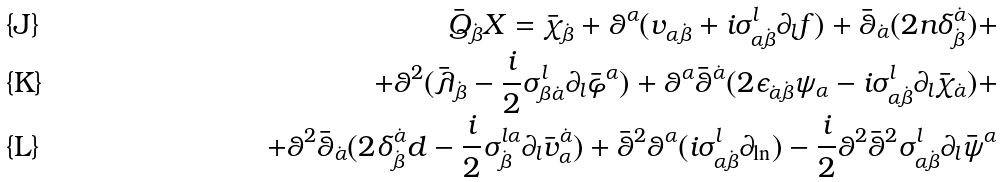Convert formula to latex. <formula><loc_0><loc_0><loc_500><loc_500>\bar { Q } _ { \dot { \beta } } X = \bar { \chi } _ { \dot { \beta } } + \theta ^ { \alpha } ( v _ { \alpha \dot { \beta } } + i \sigma _ { \alpha \dot { \beta } } ^ { l } \partial _ { l } f ) + \bar { \theta } _ { \dot { \alpha } } ( 2 n \delta _ { \dot { \beta } } ^ { \dot { \alpha } } ) + \\ + \theta ^ { 2 } ( \bar { \lambda } _ { \dot { \beta } } - \frac { i } { 2 } \sigma _ { \beta \dot { \alpha } } ^ { l } \partial _ { l } \bar { \varphi } ^ { \alpha } ) + \theta ^ { \alpha } \bar { \theta } ^ { \dot { \alpha } } ( 2 \epsilon _ { \dot { \alpha } \dot { \beta } } \psi _ { \alpha } - i \sigma _ { \alpha \dot { \beta } } ^ { l } \partial _ { l } \bar { \chi } _ { \dot { \alpha } } ) + \\ + \theta ^ { 2 } \bar { \theta } _ { \dot { \alpha } } ( 2 \delta _ { \dot { \beta } } ^ { \dot { \alpha } } d - \frac { i } { 2 } \sigma _ { \dot { \beta } } ^ { l \alpha } \partial _ { l } \bar { v } _ { \alpha } ^ { \dot { \alpha } } ) + \bar { \theta } ^ { 2 } \theta ^ { \alpha } ( i \sigma _ { \alpha \dot { \beta } } ^ { l } \partial _ { \ln } ) - \frac { i } { 2 } \theta ^ { 2 } \bar { \theta } ^ { 2 } \sigma _ { \alpha \dot { \beta } } ^ { l } \partial _ { l } \bar { \psi } ^ { \alpha }</formula> 